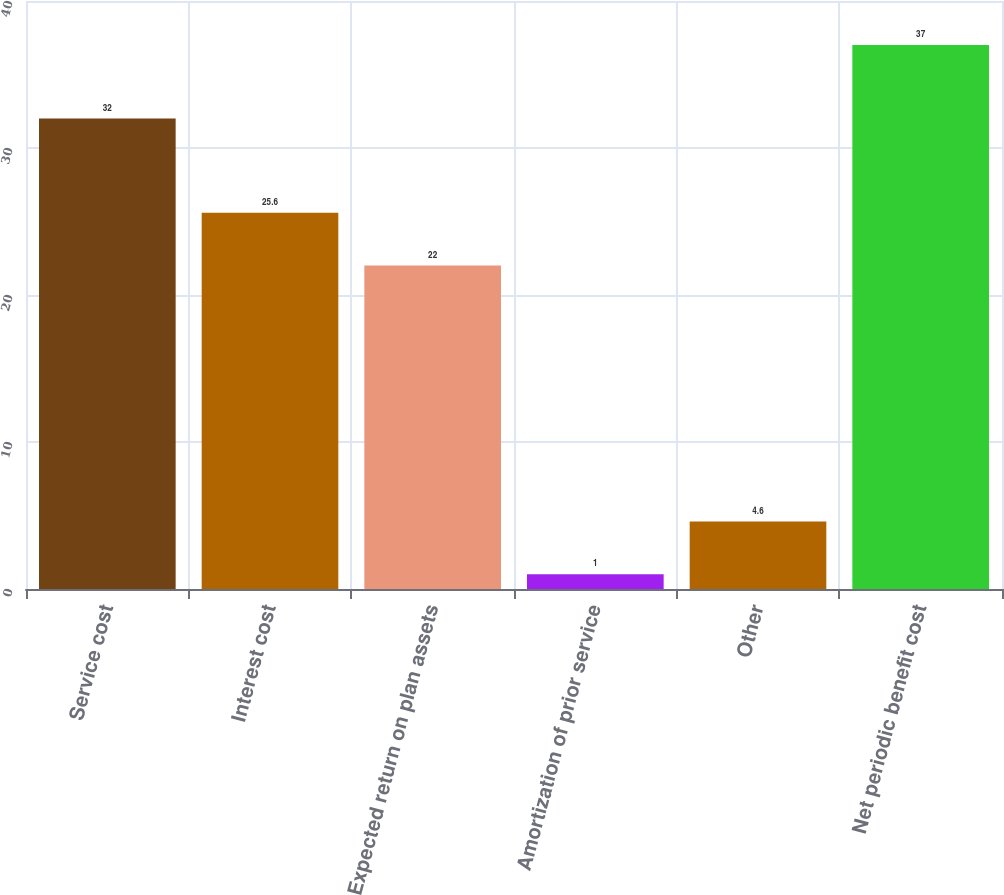Convert chart. <chart><loc_0><loc_0><loc_500><loc_500><bar_chart><fcel>Service cost<fcel>Interest cost<fcel>Expected return on plan assets<fcel>Amortization of prior service<fcel>Other<fcel>Net periodic benefit cost<nl><fcel>32<fcel>25.6<fcel>22<fcel>1<fcel>4.6<fcel>37<nl></chart> 